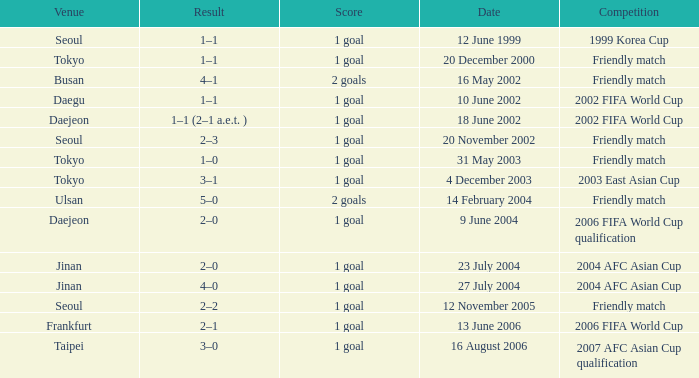What is the venue for the event on 12 November 2005? Seoul. 